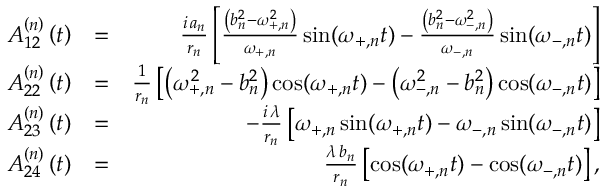<formula> <loc_0><loc_0><loc_500><loc_500>\begin{array} { r l r } { A _ { 1 2 } ^ { \left ( n \right ) } \left ( t \right ) } & { = } & { \frac { i \, a _ { n } } { r _ { n } } \left [ \frac { \left ( b _ { n } ^ { 2 } - \omega _ { + , n } ^ { 2 } \right ) } { \omega _ { + , n } } \sin ( \omega _ { + , n } t ) - \frac { \left ( b _ { n } ^ { 2 } - \omega _ { - , n } ^ { 2 } \right ) } { \omega _ { - , n } } \sin ( \omega _ { - , n } t ) \right ] } \\ { A _ { 2 2 } ^ { \left ( n \right ) } \left ( t \right ) } & { = } & { \frac { 1 } { r _ { n } } \left [ \left ( \omega _ { + , n } ^ { 2 } - b _ { n } ^ { 2 } \right ) \cos ( \omega _ { + , n } t ) - \left ( \omega _ { - , n } ^ { 2 } - b _ { n } ^ { 2 } \right ) \cos ( \omega _ { - , n } t ) \right ] } \\ { A _ { 2 3 } ^ { \left ( n \right ) } \left ( t \right ) } & { = } & { - \frac { i \, \lambda } { r _ { n } } \left [ \omega _ { + , n } \sin ( \omega _ { + , n } t ) - \omega _ { - , n } \sin ( \omega _ { - , n } t ) \right ] } \\ { A _ { 2 4 } ^ { \left ( n \right ) } \left ( t \right ) } & { = } & { \frac { \lambda \, b _ { n } } { r _ { n } } \left [ \cos ( \omega _ { + , n } t ) - \cos ( \omega _ { - , n } t ) \right ] , } \end{array}</formula> 